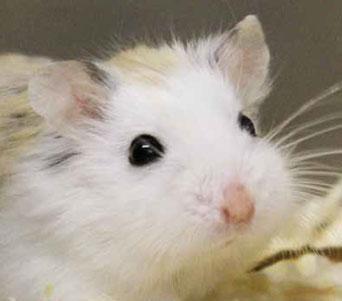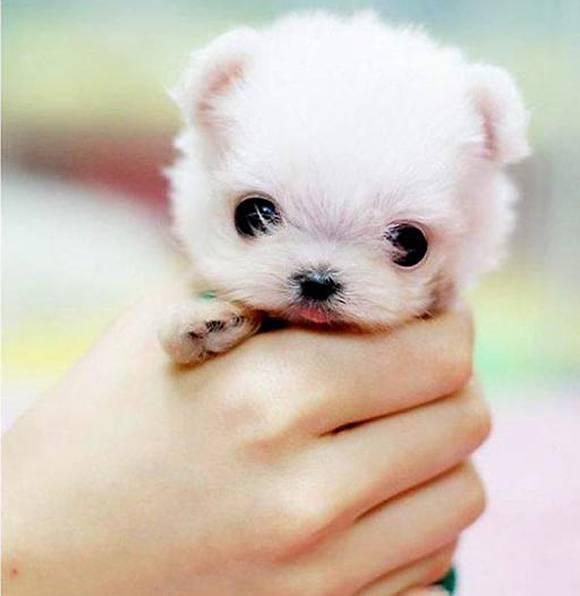The first image is the image on the left, the second image is the image on the right. Considering the images on both sides, is "An animal is eating something yellow." valid? Answer yes or no. No. 